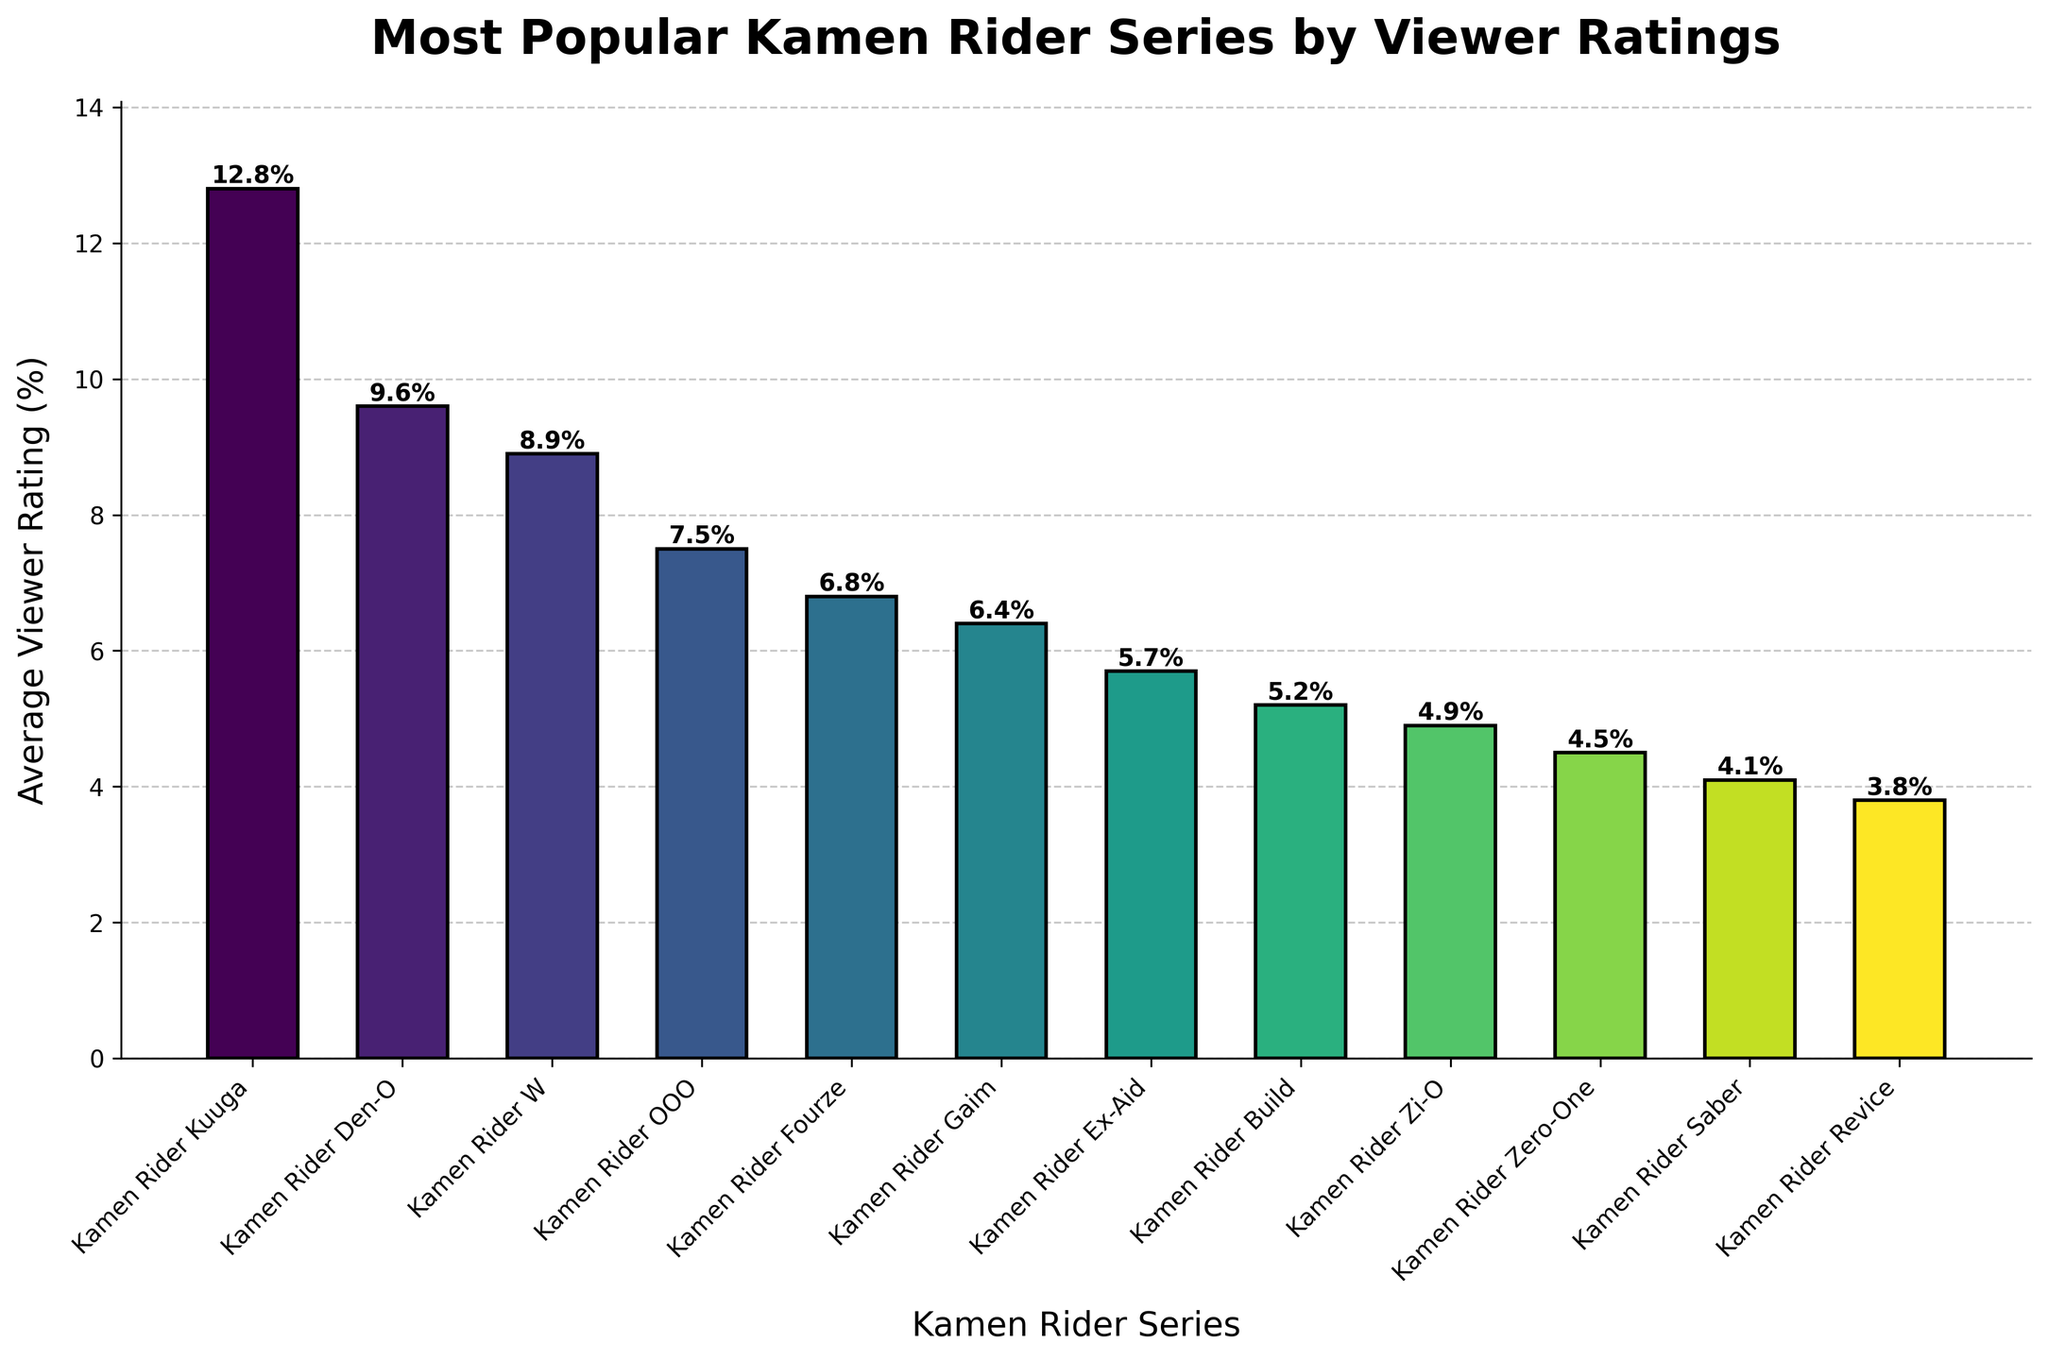Which Kamen Rider series has the highest average viewer rating? The highest bar in the figure represents "Kamen Rider Kuuga" with the highest average viewer rating.
Answer: Kamen Rider Kuuga What's the difference in average viewer rating between Kamen Rider Kuuga and Kamen Rider Revice? The average viewer rating for Kamen Rider Kuuga is 12.8%, and for Kamen Rider Revice, it is 3.8%. Subtract 3.8% from 12.8% to find the difference.
Answer: 9.0% Which series has a higher viewer rating, Kamen Rider Zi-O or Kamen Rider Saber? By visually comparing the height of the bars for Kamen Rider Zi-O and Kamen Rider Saber, Kamen Rider Zi-O has a higher viewer rating at 4.9% compared to Saber's 4.1%.
Answer: Kamen Rider Zi-O What is the combined average viewer rating of Kamen Rider OOO and Kamen Rider Fourze? Add the average viewer ratings of Kamen Rider OOO (7.5%) and Kamen Rider Fourze (6.8%). The combined rating is 7.5% + 6.8%.
Answer: 14.3% Which color shade represents the Kamen Rider Build series? The Kamen Rider Build bar, which represents an average viewer rating of 5.2%, is the 8th bar from the left in the color gradient. It is a mid-range color in the viridis color map.
Answer: Mid-range color What is the average viewer rating for the series ranked third highest? The third highest series by viewer rating is Kamen Rider W with an average viewer rating of 8.9%.
Answer: 8.9% How many series have an average viewer rating above 6%? Count the bars with heights greater than 6%: Kamen Rider Kuuga (12.8%), Kamen Rider Den-O (9.6%), Kamen Rider W (8.9%), Kamen Rider OOO (7.5%), and Kamen Rider Fourze (6.8%). There are 5 series.
Answer: 5 Which Kamen Rider series has the lowest average viewer rating, and what is its value? The shortest bar in the figure represents Kamen Rider Revice with the lowest average viewer rating.
Answer: Kamen Rider Revice, 3.8% What is the average difference in viewer ratings between consecutive series? Find the differences in percentages between consecutive series and then calculate the average. Differences: 12.8-9.6, 9.6-8.9, 8.9-7.5, 7.5-6.8, 6.8-6.4, 6.4-5.7, 5.7-5.2, 5.2-4.9, 4.9-4.5, 4.5-4.1, 4.1-3.8. Sum the differences and divide by the number of intervals (11).
Answer: ~0.9% 